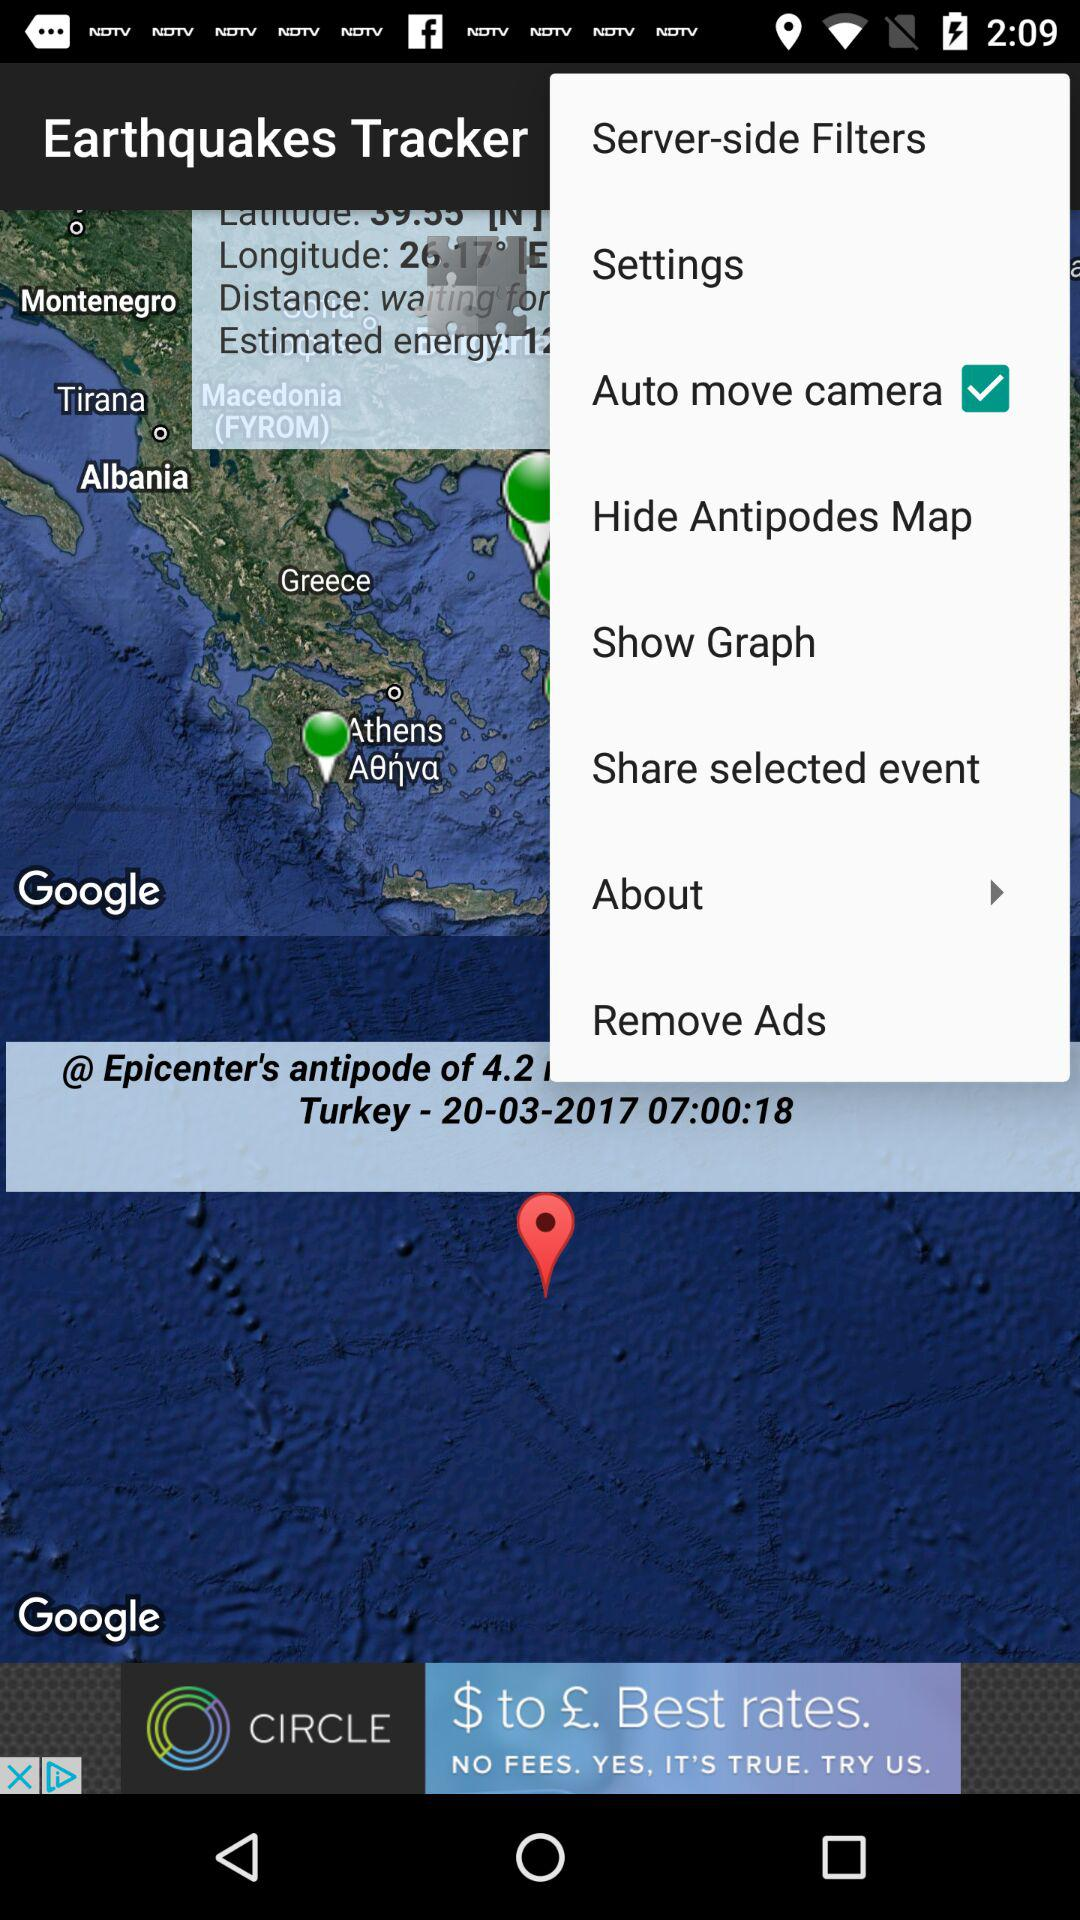What is the mentioned time? The mentioned time is 07:00:18. 